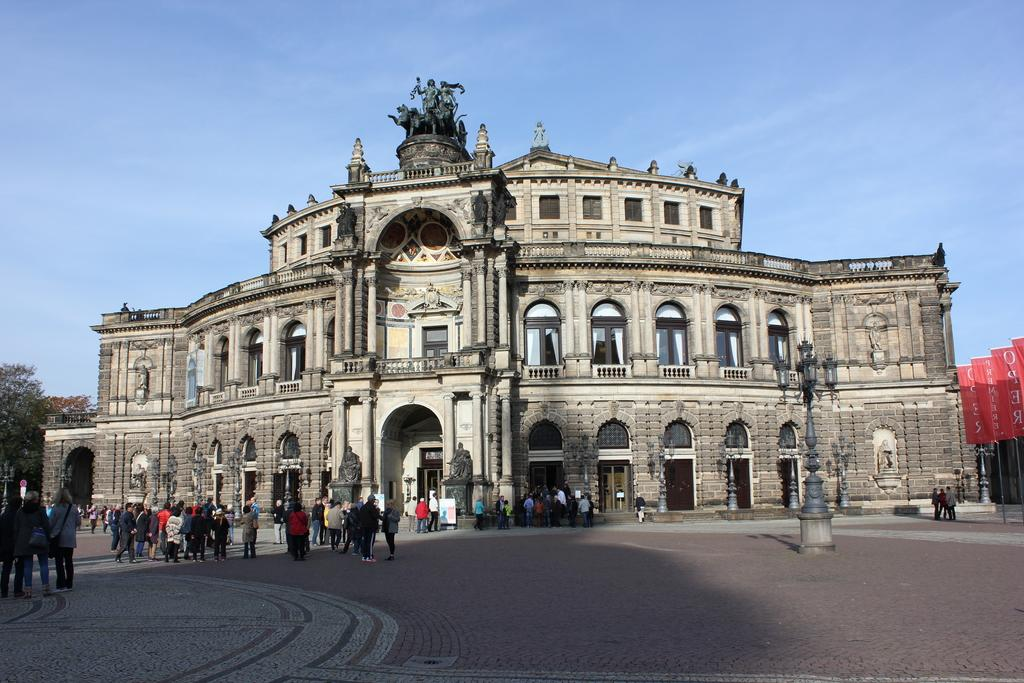What type of structures can be seen in the image? There are buildings in the image. What architectural features are visible on the buildings? There are windows visible on the buildings. What type of lighting is present in the image? There are street lamps in the image. What type of decorations are present in the image? There are banners in the image. What type of vegetation is present in the image? There are trees in the image. What type of living organisms are present in the image? There are people in the image. What is visible at the top of the image? The sky is visible at the top of the image. What type of cracker is being used to reason with the parent in the image? There is no cracker or parent present in the image. 